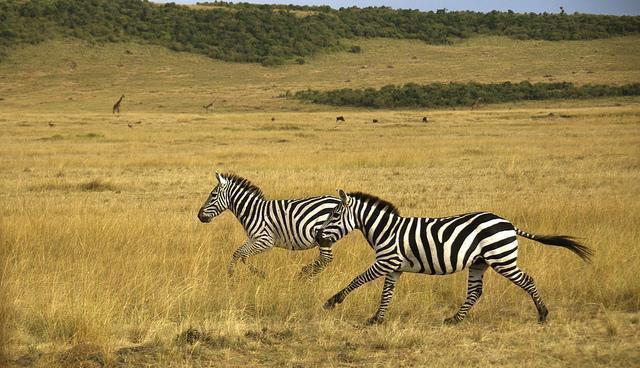How many zebras are running across the savannah plain?
Select the accurate response from the four choices given to answer the question.
Options: Three, one, two, five. Two. 